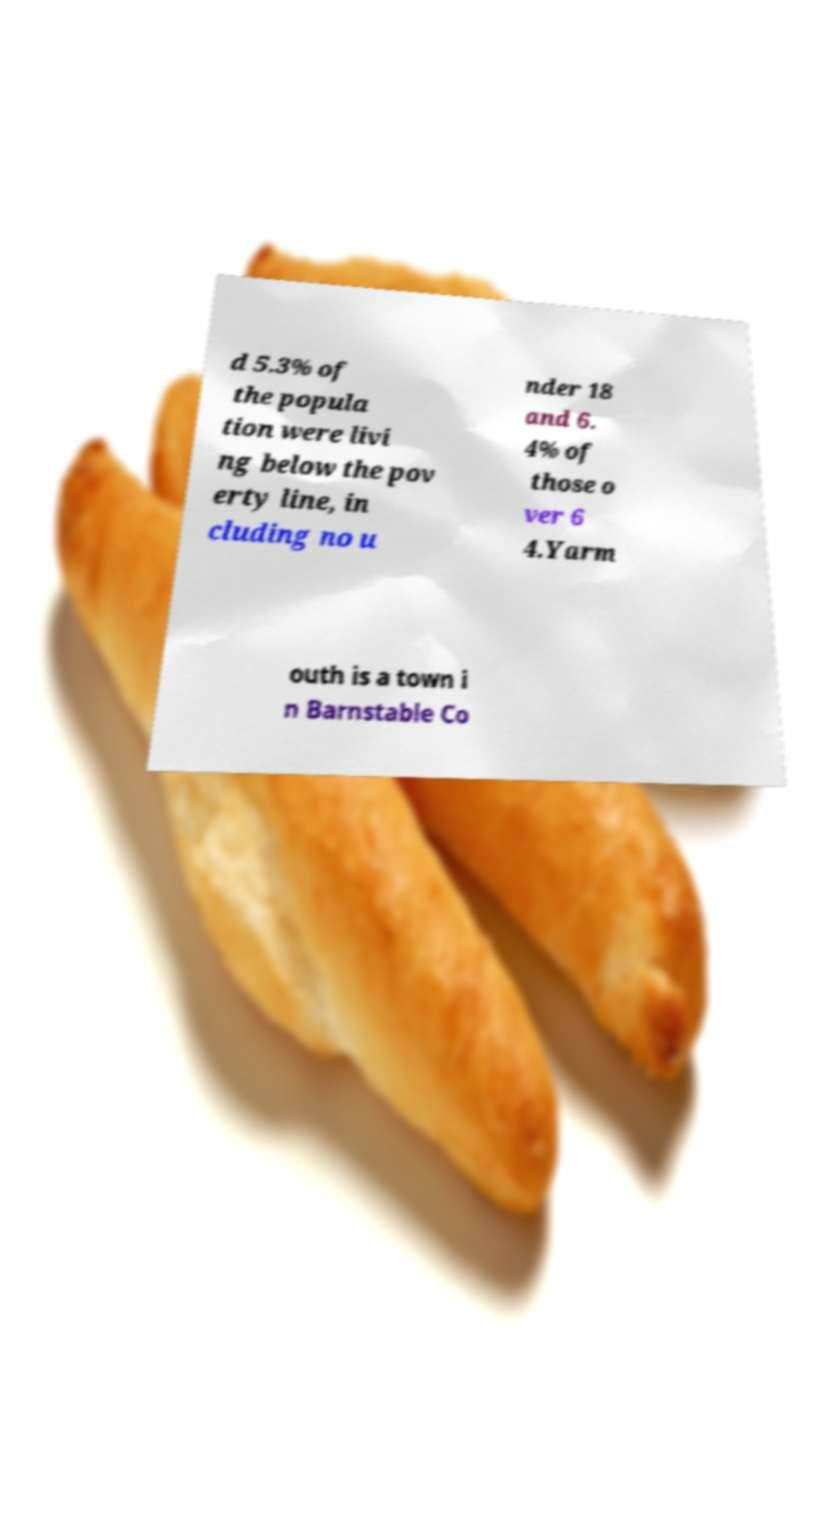For documentation purposes, I need the text within this image transcribed. Could you provide that? d 5.3% of the popula tion were livi ng below the pov erty line, in cluding no u nder 18 and 6. 4% of those o ver 6 4.Yarm outh is a town i n Barnstable Co 